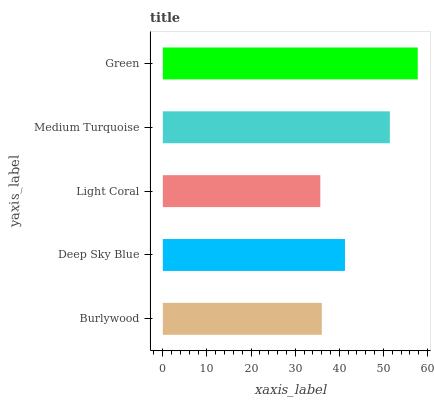Is Light Coral the minimum?
Answer yes or no. Yes. Is Green the maximum?
Answer yes or no. Yes. Is Deep Sky Blue the minimum?
Answer yes or no. No. Is Deep Sky Blue the maximum?
Answer yes or no. No. Is Deep Sky Blue greater than Burlywood?
Answer yes or no. Yes. Is Burlywood less than Deep Sky Blue?
Answer yes or no. Yes. Is Burlywood greater than Deep Sky Blue?
Answer yes or no. No. Is Deep Sky Blue less than Burlywood?
Answer yes or no. No. Is Deep Sky Blue the high median?
Answer yes or no. Yes. Is Deep Sky Blue the low median?
Answer yes or no. Yes. Is Light Coral the high median?
Answer yes or no. No. Is Light Coral the low median?
Answer yes or no. No. 